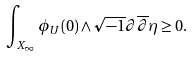<formula> <loc_0><loc_0><loc_500><loc_500>\int _ { X _ { \infty } } \phi _ { U } ( 0 ) \wedge \sqrt { - 1 } \partial \overline { \partial } \eta \geq 0 .</formula> 